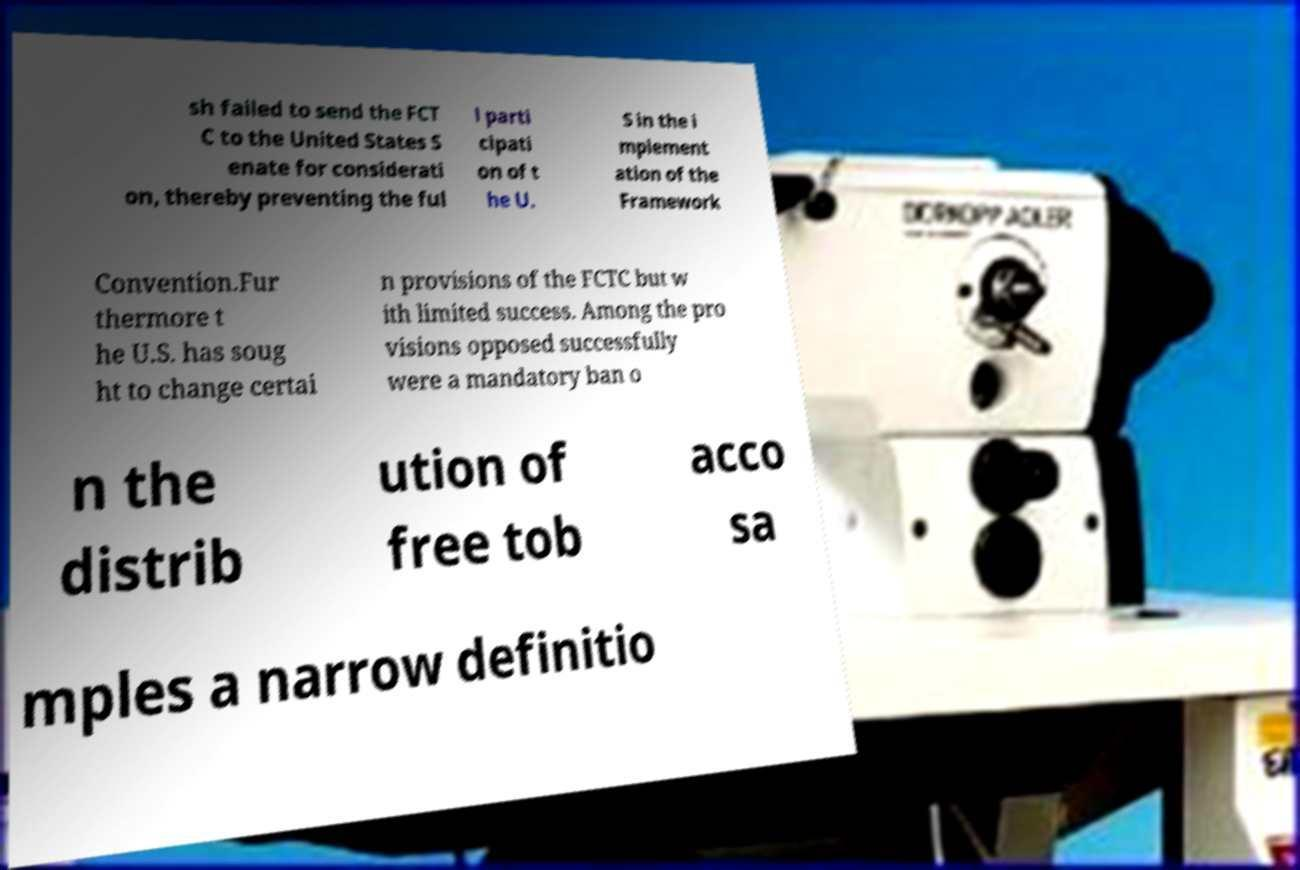Can you read and provide the text displayed in the image?This photo seems to have some interesting text. Can you extract and type it out for me? sh failed to send the FCT C to the United States S enate for considerati on, thereby preventing the ful l parti cipati on of t he U. S in the i mplement ation of the Framework Convention.Fur thermore t he U.S. has soug ht to change certai n provisions of the FCTC but w ith limited success. Among the pro visions opposed successfully were a mandatory ban o n the distrib ution of free tob acco sa mples a narrow definitio 